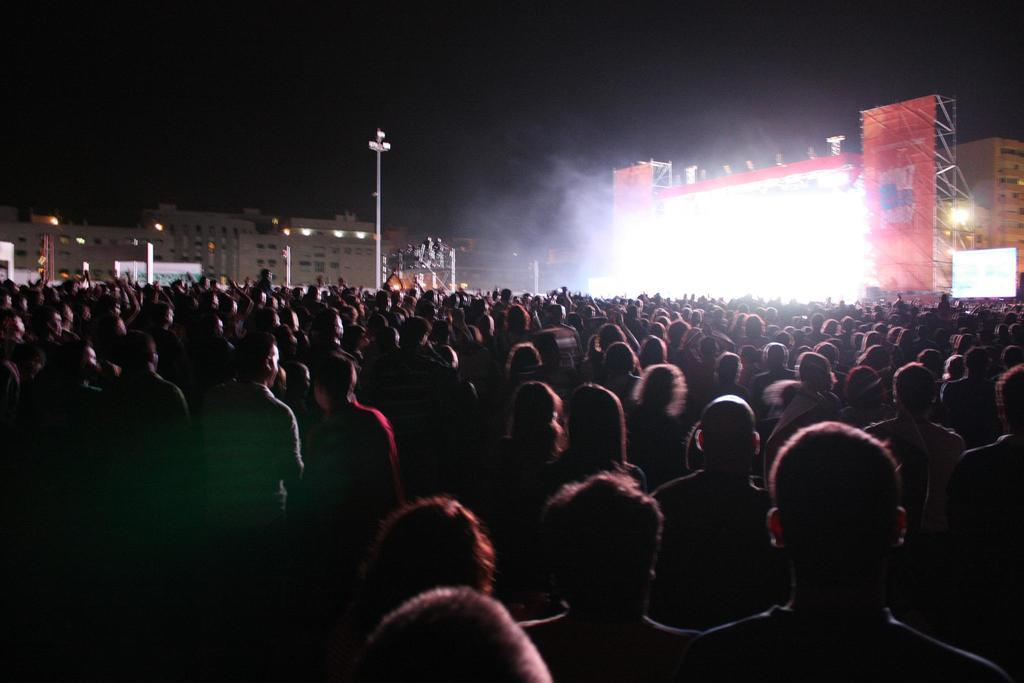How many people are in the image? There is a group of people in the image, but the exact number cannot be determined from the provided facts. What can be seen in the background of the image? There are buildings, a stage, smoke, and lights on a pole visible in the background of the image. Can you see any badges on the people in the image? There is no mention of badges in the provided facts, so it cannot be determined if any are present in the image. Is there a dock visible in the image? There is no dock mentioned in the provided facts, so it cannot be determined if one is present in the image. 